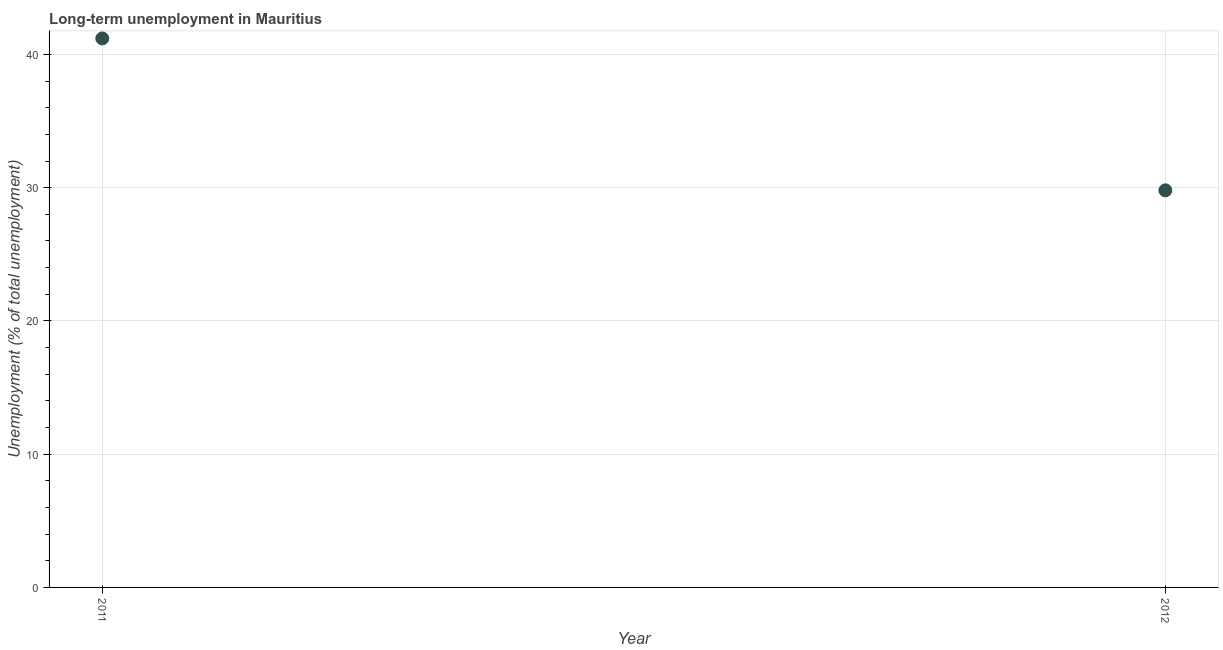What is the long-term unemployment in 2012?
Keep it short and to the point. 29.8. Across all years, what is the maximum long-term unemployment?
Offer a terse response. 41.2. Across all years, what is the minimum long-term unemployment?
Make the answer very short. 29.8. In which year was the long-term unemployment maximum?
Offer a very short reply. 2011. In which year was the long-term unemployment minimum?
Provide a short and direct response. 2012. What is the sum of the long-term unemployment?
Your answer should be compact. 71. What is the difference between the long-term unemployment in 2011 and 2012?
Offer a terse response. 11.4. What is the average long-term unemployment per year?
Your response must be concise. 35.5. What is the median long-term unemployment?
Your answer should be compact. 35.5. Do a majority of the years between 2012 and 2011 (inclusive) have long-term unemployment greater than 32 %?
Ensure brevity in your answer.  No. What is the ratio of the long-term unemployment in 2011 to that in 2012?
Your answer should be compact. 1.38. Is the long-term unemployment in 2011 less than that in 2012?
Offer a very short reply. No. How many dotlines are there?
Make the answer very short. 1. Are the values on the major ticks of Y-axis written in scientific E-notation?
Provide a succinct answer. No. Does the graph contain any zero values?
Your response must be concise. No. Does the graph contain grids?
Ensure brevity in your answer.  Yes. What is the title of the graph?
Offer a very short reply. Long-term unemployment in Mauritius. What is the label or title of the X-axis?
Provide a short and direct response. Year. What is the label or title of the Y-axis?
Provide a succinct answer. Unemployment (% of total unemployment). What is the Unemployment (% of total unemployment) in 2011?
Make the answer very short. 41.2. What is the Unemployment (% of total unemployment) in 2012?
Your answer should be very brief. 29.8. What is the ratio of the Unemployment (% of total unemployment) in 2011 to that in 2012?
Make the answer very short. 1.38. 